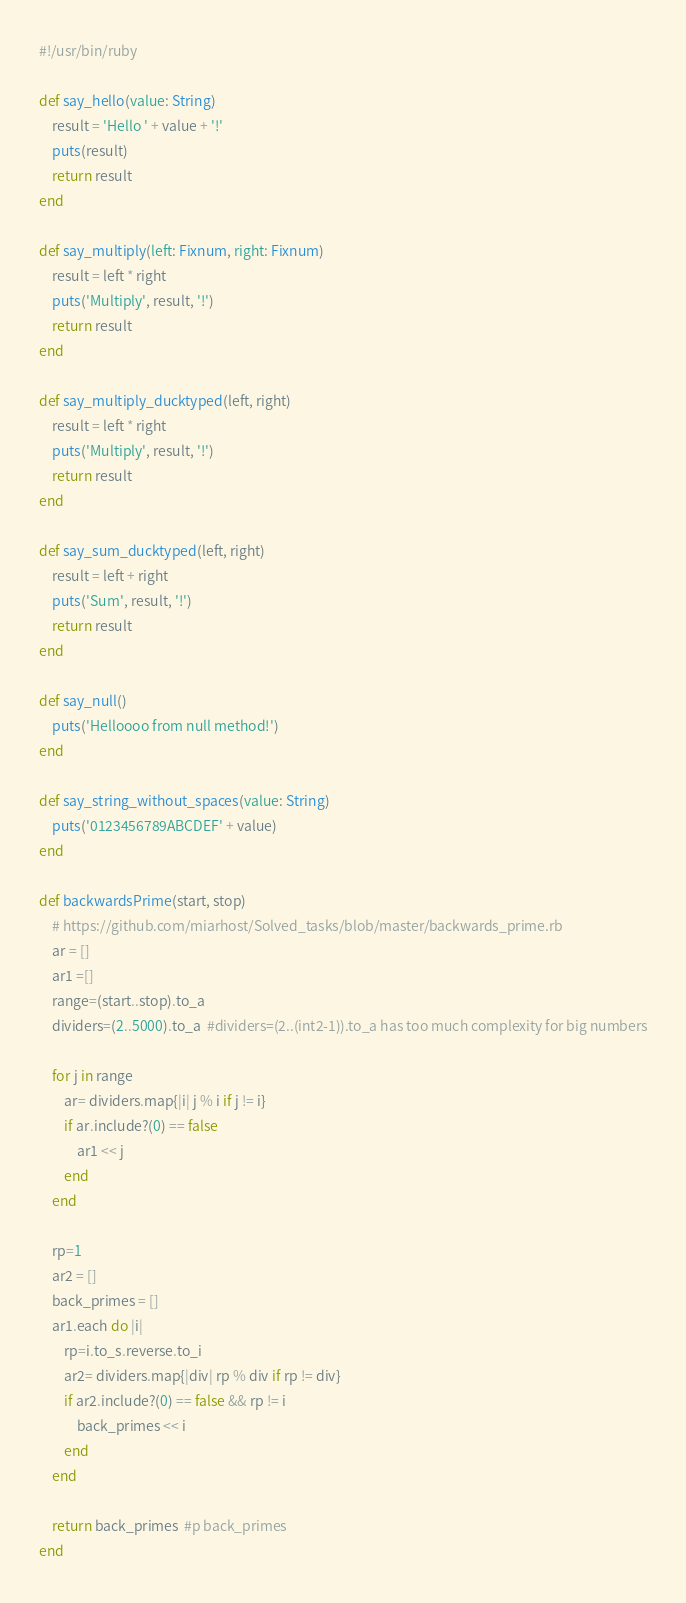<code> <loc_0><loc_0><loc_500><loc_500><_Ruby_>#!/usr/bin/ruby

def say_hello(value: String)
	result = 'Hello ' + value + '!'
	puts(result)
	return result
end

def say_multiply(left: Fixnum, right: Fixnum)
	result = left * right
	puts('Multiply', result, '!')
	return result
end

def say_multiply_ducktyped(left, right)
	result = left * right
	puts('Multiply', result, '!')
	return result
end

def say_sum_ducktyped(left, right)
	result = left + right
	puts('Sum', result, '!')
	return result
end

def say_null()
	puts('Helloooo from null method!')
end

def say_string_without_spaces(value: String)
	puts('0123456789ABCDEF' + value)
end

def backwardsPrime(start, stop)
	# https://github.com/miarhost/Solved_tasks/blob/master/backwards_prime.rb
	ar = []
	ar1 =[]
	range=(start..stop).to_a
	dividers=(2..5000).to_a  #dividers=(2..(int2-1)).to_a has too much complexity for big numbers

	for j in range
		ar= dividers.map{|i| j % i if j != i}
		if ar.include?(0) == false
			ar1 << j
		end
	end

	rp=1
	ar2 = []
	back_primes = []
	ar1.each do |i|
		rp=i.to_s.reverse.to_i
		ar2= dividers.map{|div| rp % div if rp != div}
		if ar2.include?(0) == false && rp != i
			back_primes << i
		end
	end

	return back_primes  #p back_primes
end
</code> 